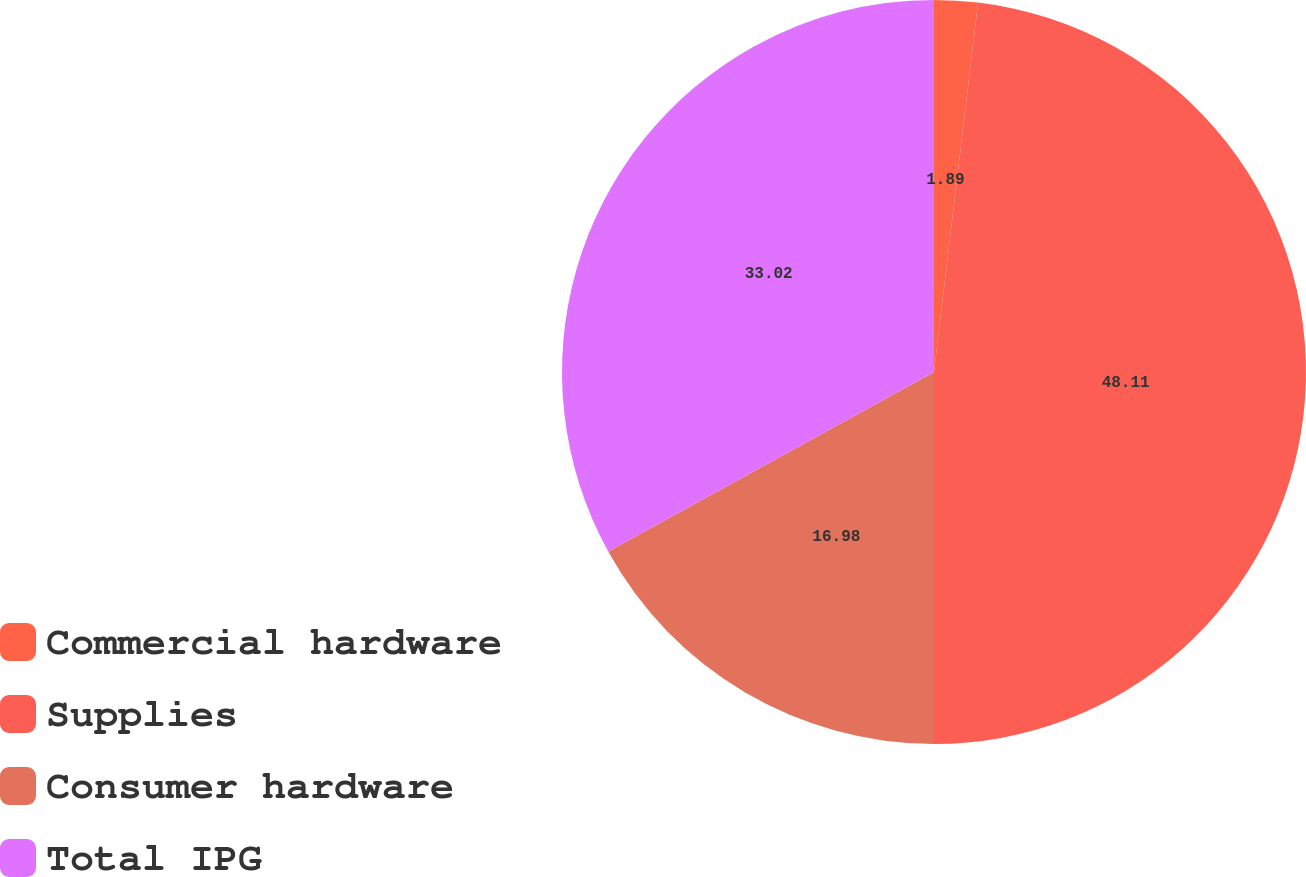<chart> <loc_0><loc_0><loc_500><loc_500><pie_chart><fcel>Commercial hardware<fcel>Supplies<fcel>Consumer hardware<fcel>Total IPG<nl><fcel>1.89%<fcel>48.11%<fcel>16.98%<fcel>33.02%<nl></chart> 